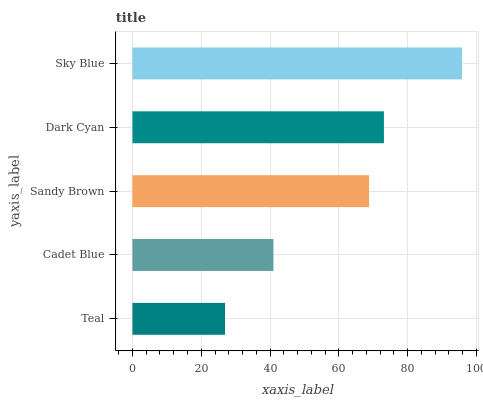Is Teal the minimum?
Answer yes or no. Yes. Is Sky Blue the maximum?
Answer yes or no. Yes. Is Cadet Blue the minimum?
Answer yes or no. No. Is Cadet Blue the maximum?
Answer yes or no. No. Is Cadet Blue greater than Teal?
Answer yes or no. Yes. Is Teal less than Cadet Blue?
Answer yes or no. Yes. Is Teal greater than Cadet Blue?
Answer yes or no. No. Is Cadet Blue less than Teal?
Answer yes or no. No. Is Sandy Brown the high median?
Answer yes or no. Yes. Is Sandy Brown the low median?
Answer yes or no. Yes. Is Teal the high median?
Answer yes or no. No. Is Dark Cyan the low median?
Answer yes or no. No. 